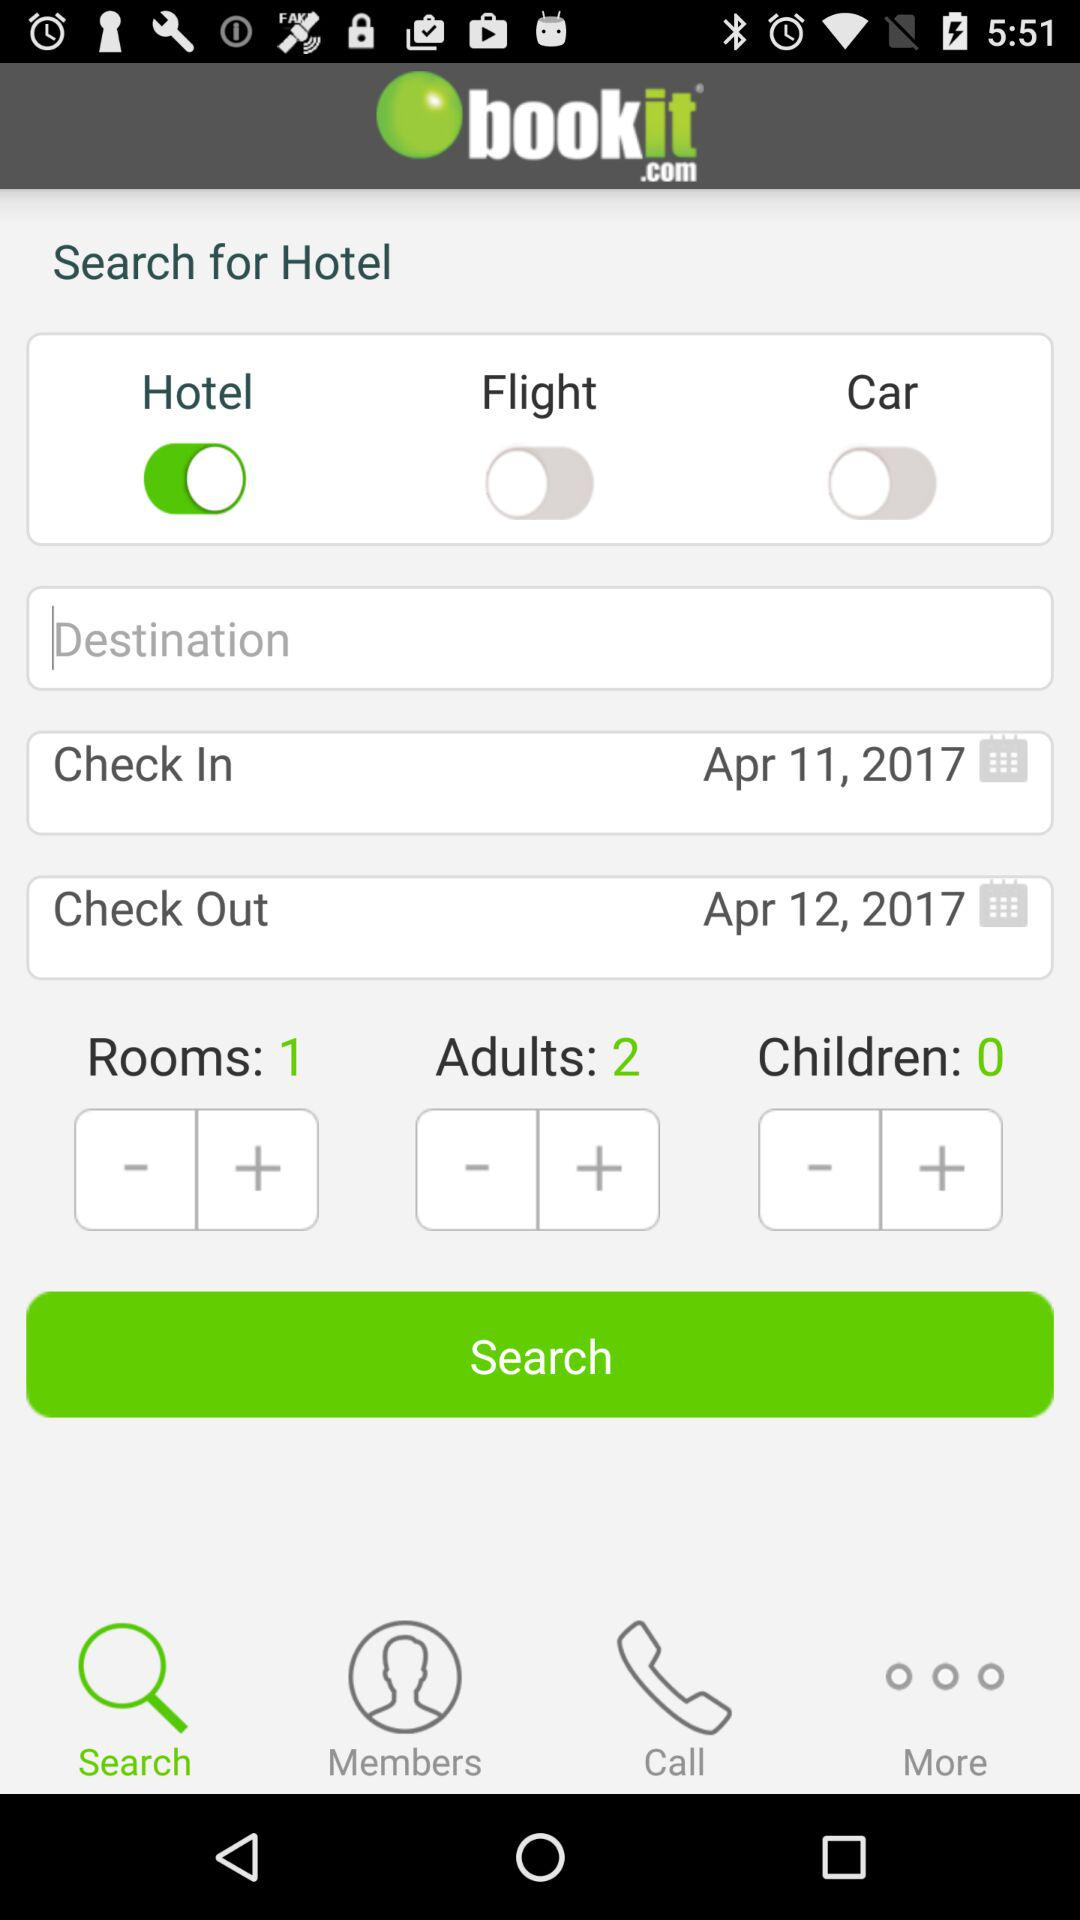What is the name of the application? The name of the application is "bookit.com". 